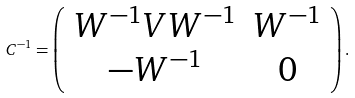<formula> <loc_0><loc_0><loc_500><loc_500>C ^ { - 1 } = \left ( \begin{array} { c c } W ^ { - 1 } V W ^ { - 1 } & W ^ { - 1 } \\ - W ^ { - 1 } & 0 \end{array} \right ) .</formula> 